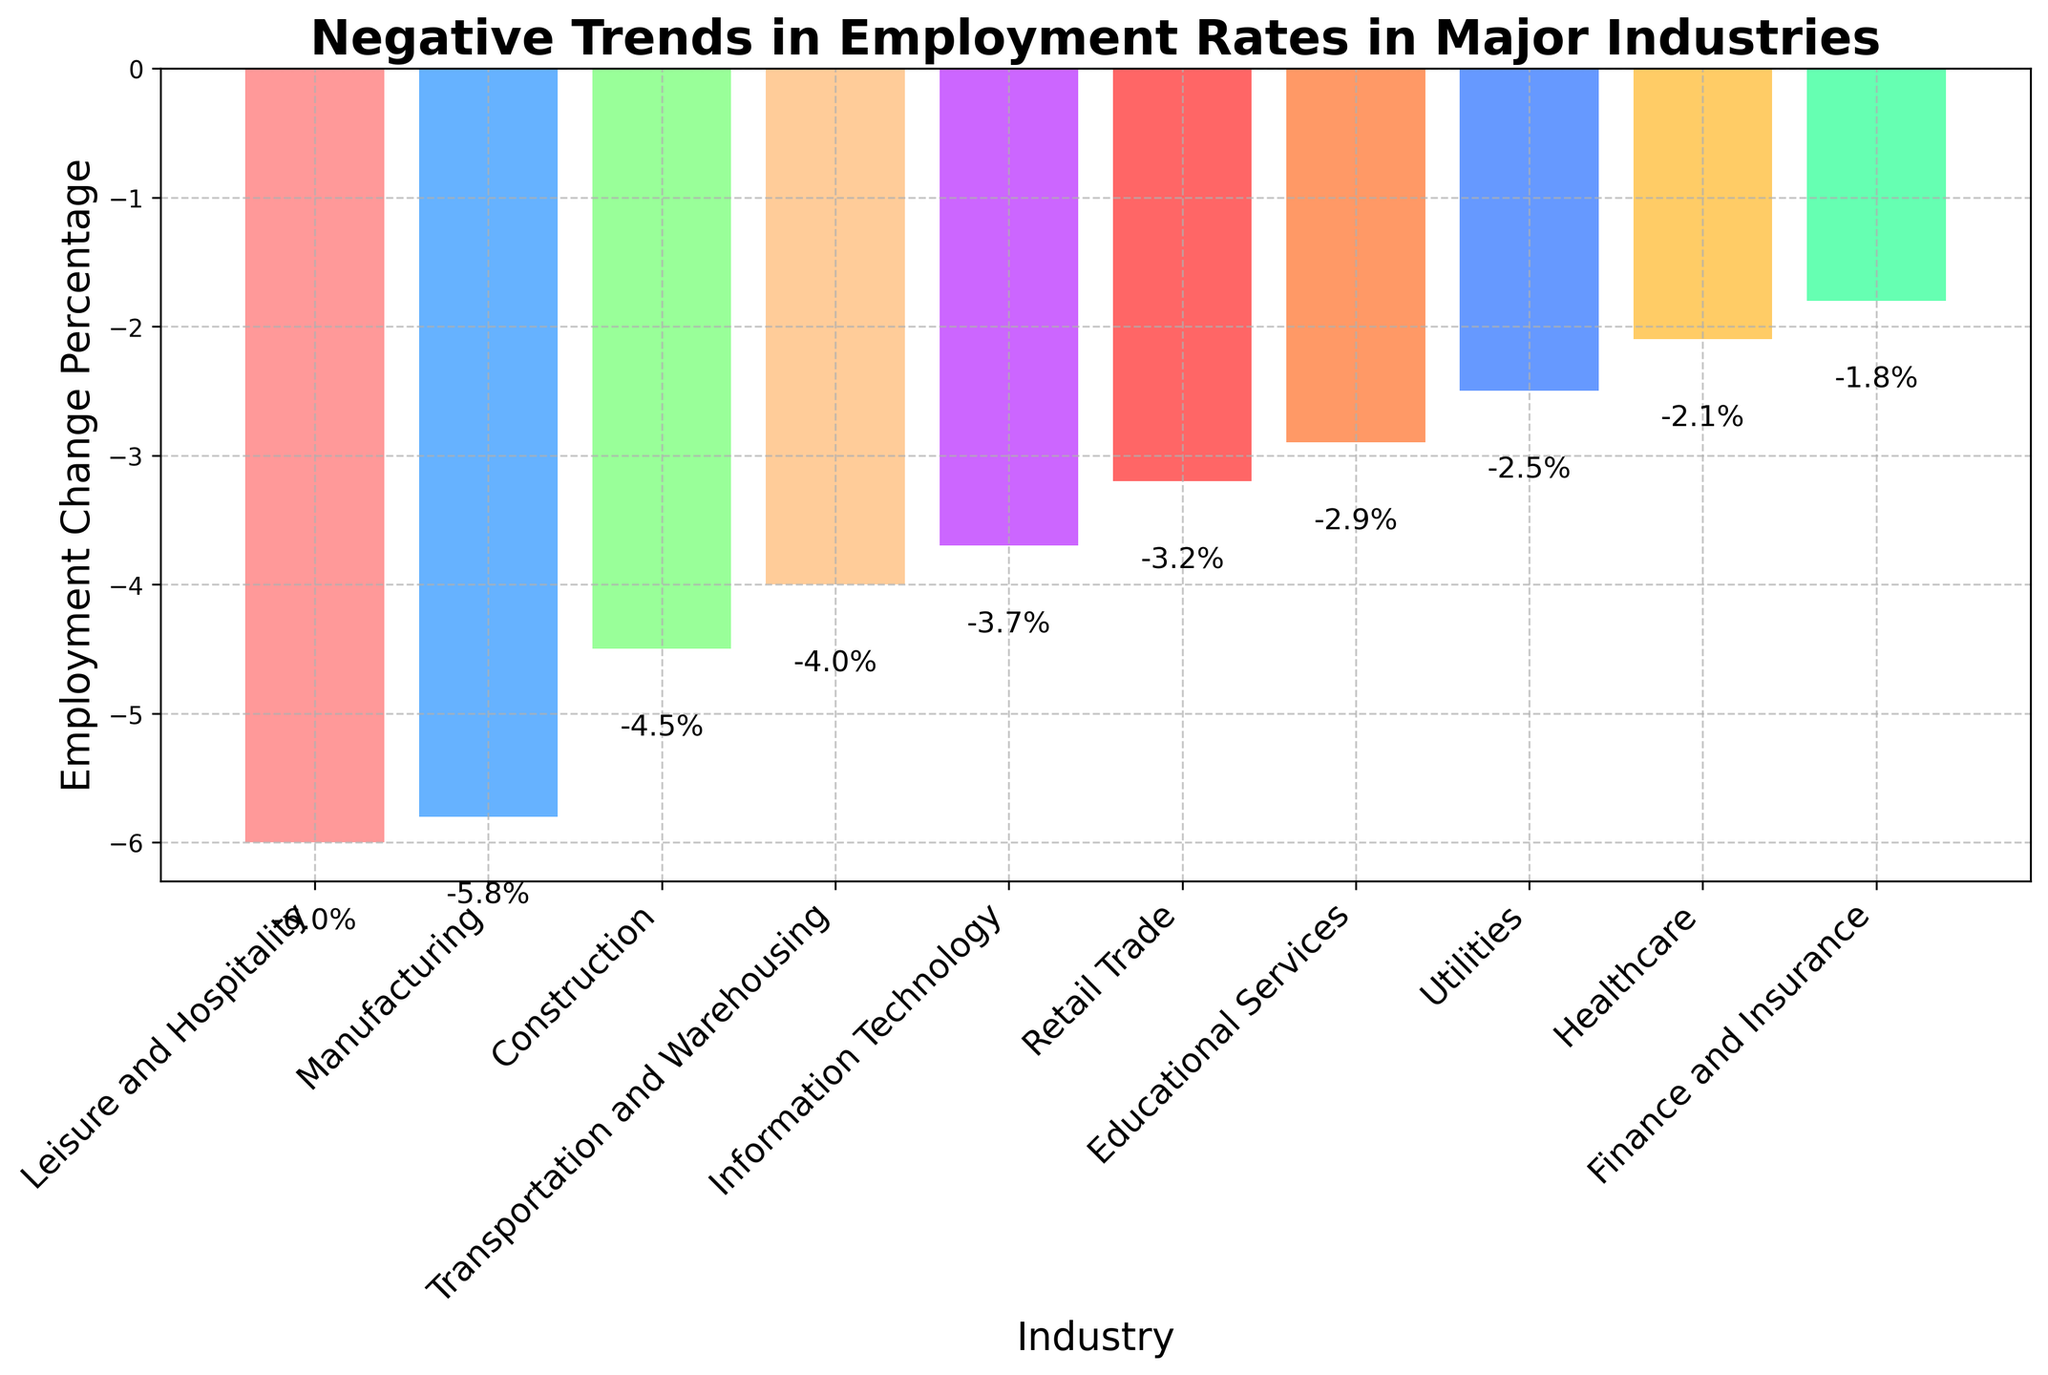What industry has the largest negative employment change percentage? To determine the industry with the largest negative employment change percentage, we compare the lengths of the bars in the chart. The bar with the greatest negative value represents the largest decline. In this chart, 'Leisure and Hospitality' has the longest bar in the negative direction.
Answer: Leisure and Hospitality Which industry has the smallest negative employment change percentage? To find the industry with the smallest negative employment change, look for the bar that is tallest in the negative direction but closest to zero. In this chart, 'Finance and Insurance' shows the shortest bar in the negative direction.
Answer: Finance and Insurance By how many percentage points is the employment change in Leisure and Hospitality more negative than that in Healthcare? Subtract the employment change percentage of Healthcare from that of Leisure and Hospitality. Leisure and Hospitality: -6.0%, Healthcare: -2.1%. So, -6.0% - (-2.1%) = -6.0% + 2.1% = -3.9%.
Answer: 3.9% What is the average negative employment change percentage across all industries? Sum up all the negative employment change percentages and divide by the number of industries. (-5.8) + (-3.2) + (-2.1) + (-4.5) + (-3.7) + (-1.8) + (-4.0) + (-2.5) + (-6.0) + (-2.9) = -36.5. With 10 industries, the average is -36.5/10 = -3.65%.
Answer: -3.65% Which industries have a more negative employment change than the average negative employment change percentage? First, calculate the average negative employment change: -3.65%. Then, identify which industries have a more negative percentage than the average: Manufacturing (-5.8%), Construction (-4.5%), Transportation and Warehousing (-4.0%), Leisure and Hospitality (-6.0%), Educational Services (-2.9%).
Answer: Manufacturing, Construction, Transportation and Warehousing, Leisure and Hospitality How does the employment change percentage in Information Technology compare with that in Retail Trade? Compare the bars for Information Technology and Retail Trade. Information Technology has a change percentage of -3.7%, and Retail Trade has a change percentage of -3.2%. Therefore, Information Technology has a more negative change compared to Retail Trade.
Answer: More negative Which two industries have the closest negative employment change percentages? To identify the industries with the closest values, look for bars of similar lengths. Educational Services (-2.9%) and Retail Trade (-3.2%) are the closest with a difference of
Answer: Educational Services, Retail Trade What is the total combined employment change percentage for Manufacturing, Construction, and Leisure and Hospitality? Add the negative employment change percentages of the three industries: Manufacturing (-5.8%), Construction (-4.5%), and Leisure and Hospitality (-6.0%). So, -5.8% + (-4.5%) + (-6.0%) = -16.3%.
Answer: -16.3% 